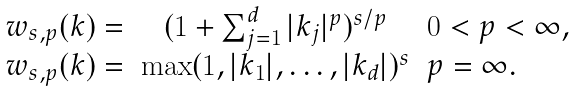Convert formula to latex. <formula><loc_0><loc_0><loc_500><loc_500>\begin{array} { r c l } w _ { s , p } ( k ) = & ( 1 + \sum _ { j = 1 } ^ { d } | k _ { j } | ^ { p } ) ^ { s / p } & 0 < p < \infty , \\ w _ { s , p } ( k ) = & \max ( 1 , | k _ { 1 } | , \dots , | k _ { d } | ) ^ { s } & p = \infty . \end{array}</formula> 